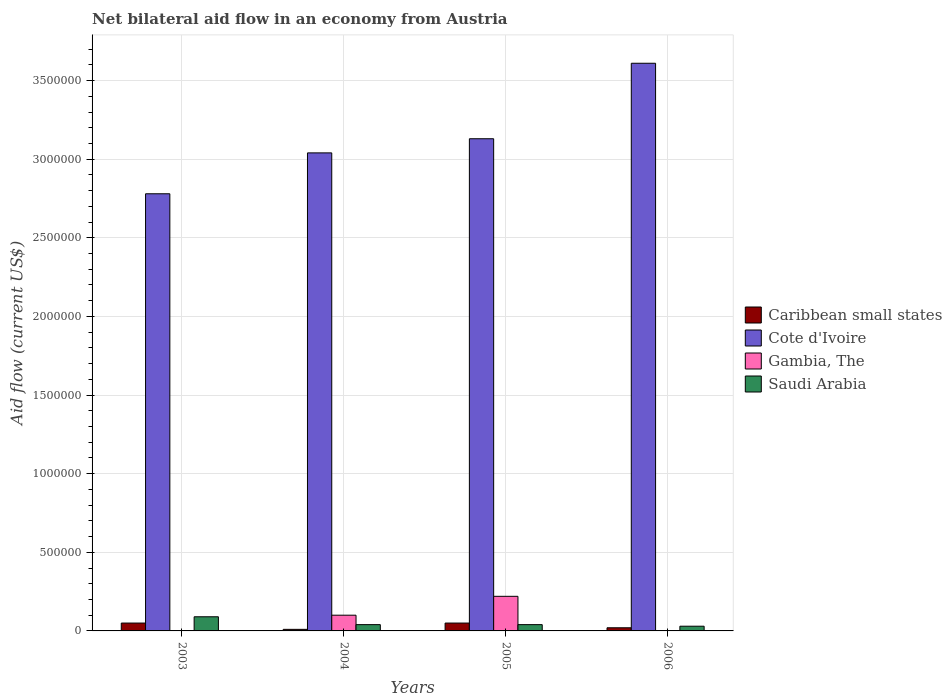Are the number of bars per tick equal to the number of legend labels?
Provide a short and direct response. No. Are the number of bars on each tick of the X-axis equal?
Make the answer very short. No. How many bars are there on the 2nd tick from the left?
Provide a short and direct response. 4. How many bars are there on the 2nd tick from the right?
Your answer should be compact. 4. What is the net bilateral aid flow in Cote d'Ivoire in 2004?
Offer a very short reply. 3.04e+06. Across all years, what is the minimum net bilateral aid flow in Saudi Arabia?
Your answer should be very brief. 3.00e+04. What is the total net bilateral aid flow in Caribbean small states in the graph?
Provide a short and direct response. 1.30e+05. What is the difference between the net bilateral aid flow in Cote d'Ivoire in 2004 and that in 2005?
Your response must be concise. -9.00e+04. What is the difference between the net bilateral aid flow in Saudi Arabia in 2003 and the net bilateral aid flow in Cote d'Ivoire in 2006?
Provide a succinct answer. -3.52e+06. What is the average net bilateral aid flow in Cote d'Ivoire per year?
Provide a succinct answer. 3.14e+06. In the year 2003, what is the difference between the net bilateral aid flow in Caribbean small states and net bilateral aid flow in Saudi Arabia?
Provide a succinct answer. -4.00e+04. In how many years, is the net bilateral aid flow in Caribbean small states greater than 1200000 US$?
Ensure brevity in your answer.  0. What is the ratio of the net bilateral aid flow in Cote d'Ivoire in 2005 to that in 2006?
Provide a short and direct response. 0.87. Is the net bilateral aid flow in Cote d'Ivoire in 2003 less than that in 2006?
Ensure brevity in your answer.  Yes. Is the difference between the net bilateral aid flow in Caribbean small states in 2003 and 2004 greater than the difference between the net bilateral aid flow in Saudi Arabia in 2003 and 2004?
Your answer should be compact. No. What is the difference between the highest and the lowest net bilateral aid flow in Saudi Arabia?
Offer a terse response. 6.00e+04. Is it the case that in every year, the sum of the net bilateral aid flow in Gambia, The and net bilateral aid flow in Saudi Arabia is greater than the sum of net bilateral aid flow in Caribbean small states and net bilateral aid flow in Cote d'Ivoire?
Offer a very short reply. No. Is it the case that in every year, the sum of the net bilateral aid flow in Caribbean small states and net bilateral aid flow in Gambia, The is greater than the net bilateral aid flow in Saudi Arabia?
Offer a very short reply. No. Are all the bars in the graph horizontal?
Give a very brief answer. No. What is the difference between two consecutive major ticks on the Y-axis?
Give a very brief answer. 5.00e+05. Does the graph contain grids?
Make the answer very short. Yes. What is the title of the graph?
Ensure brevity in your answer.  Net bilateral aid flow in an economy from Austria. Does "Zimbabwe" appear as one of the legend labels in the graph?
Your response must be concise. No. What is the label or title of the Y-axis?
Make the answer very short. Aid flow (current US$). What is the Aid flow (current US$) in Caribbean small states in 2003?
Your answer should be very brief. 5.00e+04. What is the Aid flow (current US$) of Cote d'Ivoire in 2003?
Offer a very short reply. 2.78e+06. What is the Aid flow (current US$) in Caribbean small states in 2004?
Ensure brevity in your answer.  10000. What is the Aid flow (current US$) in Cote d'Ivoire in 2004?
Provide a succinct answer. 3.04e+06. What is the Aid flow (current US$) of Cote d'Ivoire in 2005?
Offer a very short reply. 3.13e+06. What is the Aid flow (current US$) in Gambia, The in 2005?
Provide a succinct answer. 2.20e+05. What is the Aid flow (current US$) in Cote d'Ivoire in 2006?
Provide a succinct answer. 3.61e+06. What is the Aid flow (current US$) of Gambia, The in 2006?
Your answer should be compact. 0. Across all years, what is the maximum Aid flow (current US$) in Caribbean small states?
Give a very brief answer. 5.00e+04. Across all years, what is the maximum Aid flow (current US$) of Cote d'Ivoire?
Offer a very short reply. 3.61e+06. Across all years, what is the maximum Aid flow (current US$) in Gambia, The?
Provide a short and direct response. 2.20e+05. Across all years, what is the maximum Aid flow (current US$) in Saudi Arabia?
Your answer should be very brief. 9.00e+04. Across all years, what is the minimum Aid flow (current US$) of Caribbean small states?
Make the answer very short. 10000. Across all years, what is the minimum Aid flow (current US$) in Cote d'Ivoire?
Make the answer very short. 2.78e+06. What is the total Aid flow (current US$) in Caribbean small states in the graph?
Your response must be concise. 1.30e+05. What is the total Aid flow (current US$) in Cote d'Ivoire in the graph?
Offer a terse response. 1.26e+07. What is the total Aid flow (current US$) in Saudi Arabia in the graph?
Offer a terse response. 2.00e+05. What is the difference between the Aid flow (current US$) in Caribbean small states in 2003 and that in 2004?
Ensure brevity in your answer.  4.00e+04. What is the difference between the Aid flow (current US$) in Cote d'Ivoire in 2003 and that in 2004?
Your answer should be compact. -2.60e+05. What is the difference between the Aid flow (current US$) in Caribbean small states in 2003 and that in 2005?
Your answer should be very brief. 0. What is the difference between the Aid flow (current US$) of Cote d'Ivoire in 2003 and that in 2005?
Provide a short and direct response. -3.50e+05. What is the difference between the Aid flow (current US$) in Cote d'Ivoire in 2003 and that in 2006?
Make the answer very short. -8.30e+05. What is the difference between the Aid flow (current US$) in Cote d'Ivoire in 2004 and that in 2005?
Offer a very short reply. -9.00e+04. What is the difference between the Aid flow (current US$) in Gambia, The in 2004 and that in 2005?
Your response must be concise. -1.20e+05. What is the difference between the Aid flow (current US$) of Saudi Arabia in 2004 and that in 2005?
Provide a short and direct response. 0. What is the difference between the Aid flow (current US$) of Caribbean small states in 2004 and that in 2006?
Keep it short and to the point. -10000. What is the difference between the Aid flow (current US$) of Cote d'Ivoire in 2004 and that in 2006?
Offer a terse response. -5.70e+05. What is the difference between the Aid flow (current US$) of Caribbean small states in 2005 and that in 2006?
Offer a terse response. 3.00e+04. What is the difference between the Aid flow (current US$) in Cote d'Ivoire in 2005 and that in 2006?
Offer a terse response. -4.80e+05. What is the difference between the Aid flow (current US$) of Saudi Arabia in 2005 and that in 2006?
Your answer should be compact. 10000. What is the difference between the Aid flow (current US$) of Caribbean small states in 2003 and the Aid flow (current US$) of Cote d'Ivoire in 2004?
Ensure brevity in your answer.  -2.99e+06. What is the difference between the Aid flow (current US$) in Caribbean small states in 2003 and the Aid flow (current US$) in Gambia, The in 2004?
Ensure brevity in your answer.  -5.00e+04. What is the difference between the Aid flow (current US$) in Cote d'Ivoire in 2003 and the Aid flow (current US$) in Gambia, The in 2004?
Ensure brevity in your answer.  2.68e+06. What is the difference between the Aid flow (current US$) in Cote d'Ivoire in 2003 and the Aid flow (current US$) in Saudi Arabia in 2004?
Give a very brief answer. 2.74e+06. What is the difference between the Aid flow (current US$) in Caribbean small states in 2003 and the Aid flow (current US$) in Cote d'Ivoire in 2005?
Offer a terse response. -3.08e+06. What is the difference between the Aid flow (current US$) of Caribbean small states in 2003 and the Aid flow (current US$) of Gambia, The in 2005?
Give a very brief answer. -1.70e+05. What is the difference between the Aid flow (current US$) in Caribbean small states in 2003 and the Aid flow (current US$) in Saudi Arabia in 2005?
Your answer should be compact. 10000. What is the difference between the Aid flow (current US$) in Cote d'Ivoire in 2003 and the Aid flow (current US$) in Gambia, The in 2005?
Keep it short and to the point. 2.56e+06. What is the difference between the Aid flow (current US$) of Cote d'Ivoire in 2003 and the Aid flow (current US$) of Saudi Arabia in 2005?
Give a very brief answer. 2.74e+06. What is the difference between the Aid flow (current US$) in Caribbean small states in 2003 and the Aid flow (current US$) in Cote d'Ivoire in 2006?
Keep it short and to the point. -3.56e+06. What is the difference between the Aid flow (current US$) of Caribbean small states in 2003 and the Aid flow (current US$) of Saudi Arabia in 2006?
Your answer should be very brief. 2.00e+04. What is the difference between the Aid flow (current US$) of Cote d'Ivoire in 2003 and the Aid flow (current US$) of Saudi Arabia in 2006?
Give a very brief answer. 2.75e+06. What is the difference between the Aid flow (current US$) of Caribbean small states in 2004 and the Aid flow (current US$) of Cote d'Ivoire in 2005?
Give a very brief answer. -3.12e+06. What is the difference between the Aid flow (current US$) of Caribbean small states in 2004 and the Aid flow (current US$) of Gambia, The in 2005?
Give a very brief answer. -2.10e+05. What is the difference between the Aid flow (current US$) in Caribbean small states in 2004 and the Aid flow (current US$) in Saudi Arabia in 2005?
Ensure brevity in your answer.  -3.00e+04. What is the difference between the Aid flow (current US$) in Cote d'Ivoire in 2004 and the Aid flow (current US$) in Gambia, The in 2005?
Provide a succinct answer. 2.82e+06. What is the difference between the Aid flow (current US$) of Gambia, The in 2004 and the Aid flow (current US$) of Saudi Arabia in 2005?
Your answer should be compact. 6.00e+04. What is the difference between the Aid flow (current US$) in Caribbean small states in 2004 and the Aid flow (current US$) in Cote d'Ivoire in 2006?
Offer a terse response. -3.60e+06. What is the difference between the Aid flow (current US$) of Caribbean small states in 2004 and the Aid flow (current US$) of Saudi Arabia in 2006?
Offer a terse response. -2.00e+04. What is the difference between the Aid flow (current US$) of Cote d'Ivoire in 2004 and the Aid flow (current US$) of Saudi Arabia in 2006?
Offer a terse response. 3.01e+06. What is the difference between the Aid flow (current US$) in Gambia, The in 2004 and the Aid flow (current US$) in Saudi Arabia in 2006?
Offer a very short reply. 7.00e+04. What is the difference between the Aid flow (current US$) in Caribbean small states in 2005 and the Aid flow (current US$) in Cote d'Ivoire in 2006?
Make the answer very short. -3.56e+06. What is the difference between the Aid flow (current US$) of Caribbean small states in 2005 and the Aid flow (current US$) of Saudi Arabia in 2006?
Ensure brevity in your answer.  2.00e+04. What is the difference between the Aid flow (current US$) in Cote d'Ivoire in 2005 and the Aid flow (current US$) in Saudi Arabia in 2006?
Your response must be concise. 3.10e+06. What is the average Aid flow (current US$) in Caribbean small states per year?
Your response must be concise. 3.25e+04. What is the average Aid flow (current US$) in Cote d'Ivoire per year?
Your answer should be compact. 3.14e+06. What is the average Aid flow (current US$) of Gambia, The per year?
Ensure brevity in your answer.  8.00e+04. What is the average Aid flow (current US$) in Saudi Arabia per year?
Offer a terse response. 5.00e+04. In the year 2003, what is the difference between the Aid flow (current US$) of Caribbean small states and Aid flow (current US$) of Cote d'Ivoire?
Provide a short and direct response. -2.73e+06. In the year 2003, what is the difference between the Aid flow (current US$) of Cote d'Ivoire and Aid flow (current US$) of Saudi Arabia?
Provide a short and direct response. 2.69e+06. In the year 2004, what is the difference between the Aid flow (current US$) in Caribbean small states and Aid flow (current US$) in Cote d'Ivoire?
Keep it short and to the point. -3.03e+06. In the year 2004, what is the difference between the Aid flow (current US$) of Cote d'Ivoire and Aid flow (current US$) of Gambia, The?
Make the answer very short. 2.94e+06. In the year 2004, what is the difference between the Aid flow (current US$) of Gambia, The and Aid flow (current US$) of Saudi Arabia?
Provide a short and direct response. 6.00e+04. In the year 2005, what is the difference between the Aid flow (current US$) in Caribbean small states and Aid flow (current US$) in Cote d'Ivoire?
Your answer should be very brief. -3.08e+06. In the year 2005, what is the difference between the Aid flow (current US$) in Caribbean small states and Aid flow (current US$) in Saudi Arabia?
Provide a short and direct response. 10000. In the year 2005, what is the difference between the Aid flow (current US$) of Cote d'Ivoire and Aid flow (current US$) of Gambia, The?
Give a very brief answer. 2.91e+06. In the year 2005, what is the difference between the Aid flow (current US$) in Cote d'Ivoire and Aid flow (current US$) in Saudi Arabia?
Offer a terse response. 3.09e+06. In the year 2006, what is the difference between the Aid flow (current US$) of Caribbean small states and Aid flow (current US$) of Cote d'Ivoire?
Offer a very short reply. -3.59e+06. In the year 2006, what is the difference between the Aid flow (current US$) in Caribbean small states and Aid flow (current US$) in Saudi Arabia?
Your answer should be very brief. -10000. In the year 2006, what is the difference between the Aid flow (current US$) in Cote d'Ivoire and Aid flow (current US$) in Saudi Arabia?
Keep it short and to the point. 3.58e+06. What is the ratio of the Aid flow (current US$) in Caribbean small states in 2003 to that in 2004?
Provide a succinct answer. 5. What is the ratio of the Aid flow (current US$) in Cote d'Ivoire in 2003 to that in 2004?
Offer a terse response. 0.91. What is the ratio of the Aid flow (current US$) in Saudi Arabia in 2003 to that in 2004?
Offer a terse response. 2.25. What is the ratio of the Aid flow (current US$) in Cote d'Ivoire in 2003 to that in 2005?
Ensure brevity in your answer.  0.89. What is the ratio of the Aid flow (current US$) of Saudi Arabia in 2003 to that in 2005?
Make the answer very short. 2.25. What is the ratio of the Aid flow (current US$) in Caribbean small states in 2003 to that in 2006?
Provide a short and direct response. 2.5. What is the ratio of the Aid flow (current US$) of Cote d'Ivoire in 2003 to that in 2006?
Provide a succinct answer. 0.77. What is the ratio of the Aid flow (current US$) in Cote d'Ivoire in 2004 to that in 2005?
Offer a terse response. 0.97. What is the ratio of the Aid flow (current US$) in Gambia, The in 2004 to that in 2005?
Offer a very short reply. 0.45. What is the ratio of the Aid flow (current US$) of Caribbean small states in 2004 to that in 2006?
Ensure brevity in your answer.  0.5. What is the ratio of the Aid flow (current US$) of Cote d'Ivoire in 2004 to that in 2006?
Your response must be concise. 0.84. What is the ratio of the Aid flow (current US$) in Cote d'Ivoire in 2005 to that in 2006?
Give a very brief answer. 0.87. What is the difference between the highest and the second highest Aid flow (current US$) of Caribbean small states?
Provide a succinct answer. 0. What is the difference between the highest and the second highest Aid flow (current US$) of Saudi Arabia?
Your answer should be very brief. 5.00e+04. What is the difference between the highest and the lowest Aid flow (current US$) in Caribbean small states?
Make the answer very short. 4.00e+04. What is the difference between the highest and the lowest Aid flow (current US$) of Cote d'Ivoire?
Ensure brevity in your answer.  8.30e+05. What is the difference between the highest and the lowest Aid flow (current US$) in Gambia, The?
Offer a terse response. 2.20e+05. What is the difference between the highest and the lowest Aid flow (current US$) in Saudi Arabia?
Keep it short and to the point. 6.00e+04. 